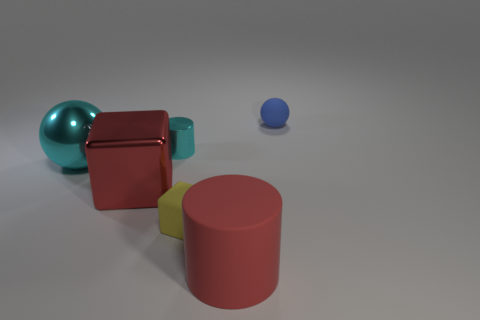Are there more small matte blocks that are to the right of the cyan metallic ball than tiny yellow things to the right of the small shiny object? There are no small matte blocks right of the cyan metallic ball, and no tiny yellow things to the right of any small shiny objects in the image. We only see a large cyan metallic ball, a small blue ball, and several other geometric shapes with different colors and textures. 